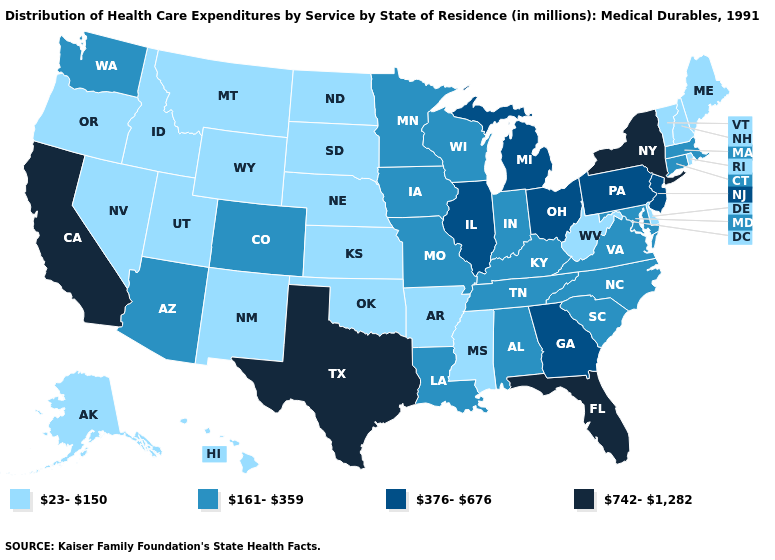What is the highest value in states that border Iowa?
Keep it brief. 376-676. Does the first symbol in the legend represent the smallest category?
Concise answer only. Yes. What is the highest value in the West ?
Write a very short answer. 742-1,282. Does the first symbol in the legend represent the smallest category?
Write a very short answer. Yes. What is the value of South Carolina?
Short answer required. 161-359. Which states hav the highest value in the West?
Give a very brief answer. California. Does Maryland have a higher value than Ohio?
Short answer required. No. What is the lowest value in states that border Delaware?
Short answer required. 161-359. Name the states that have a value in the range 23-150?
Write a very short answer. Alaska, Arkansas, Delaware, Hawaii, Idaho, Kansas, Maine, Mississippi, Montana, Nebraska, Nevada, New Hampshire, New Mexico, North Dakota, Oklahoma, Oregon, Rhode Island, South Dakota, Utah, Vermont, West Virginia, Wyoming. Name the states that have a value in the range 742-1,282?
Short answer required. California, Florida, New York, Texas. Among the states that border Idaho , which have the highest value?
Quick response, please. Washington. Name the states that have a value in the range 742-1,282?
Write a very short answer. California, Florida, New York, Texas. Name the states that have a value in the range 161-359?
Write a very short answer. Alabama, Arizona, Colorado, Connecticut, Indiana, Iowa, Kentucky, Louisiana, Maryland, Massachusetts, Minnesota, Missouri, North Carolina, South Carolina, Tennessee, Virginia, Washington, Wisconsin. What is the value of Massachusetts?
Keep it brief. 161-359. Name the states that have a value in the range 23-150?
Be succinct. Alaska, Arkansas, Delaware, Hawaii, Idaho, Kansas, Maine, Mississippi, Montana, Nebraska, Nevada, New Hampshire, New Mexico, North Dakota, Oklahoma, Oregon, Rhode Island, South Dakota, Utah, Vermont, West Virginia, Wyoming. 